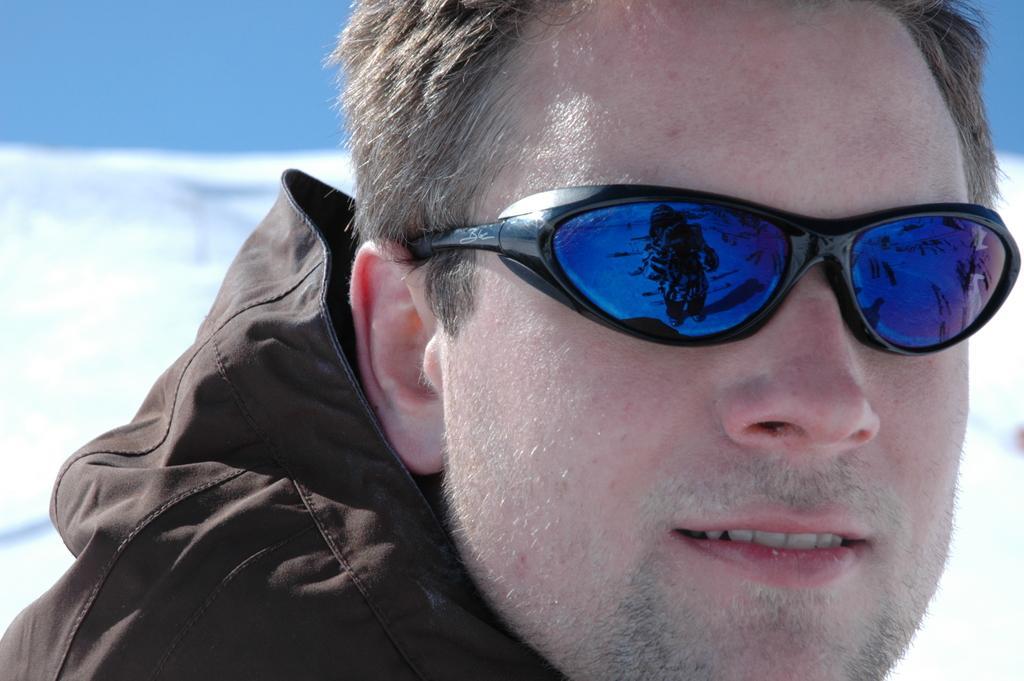In one or two sentences, can you explain what this image depicts? In the foreground I can see a person is wearing a goggle. In the background I can see ice and the blue sky. This image is taken during a day. 